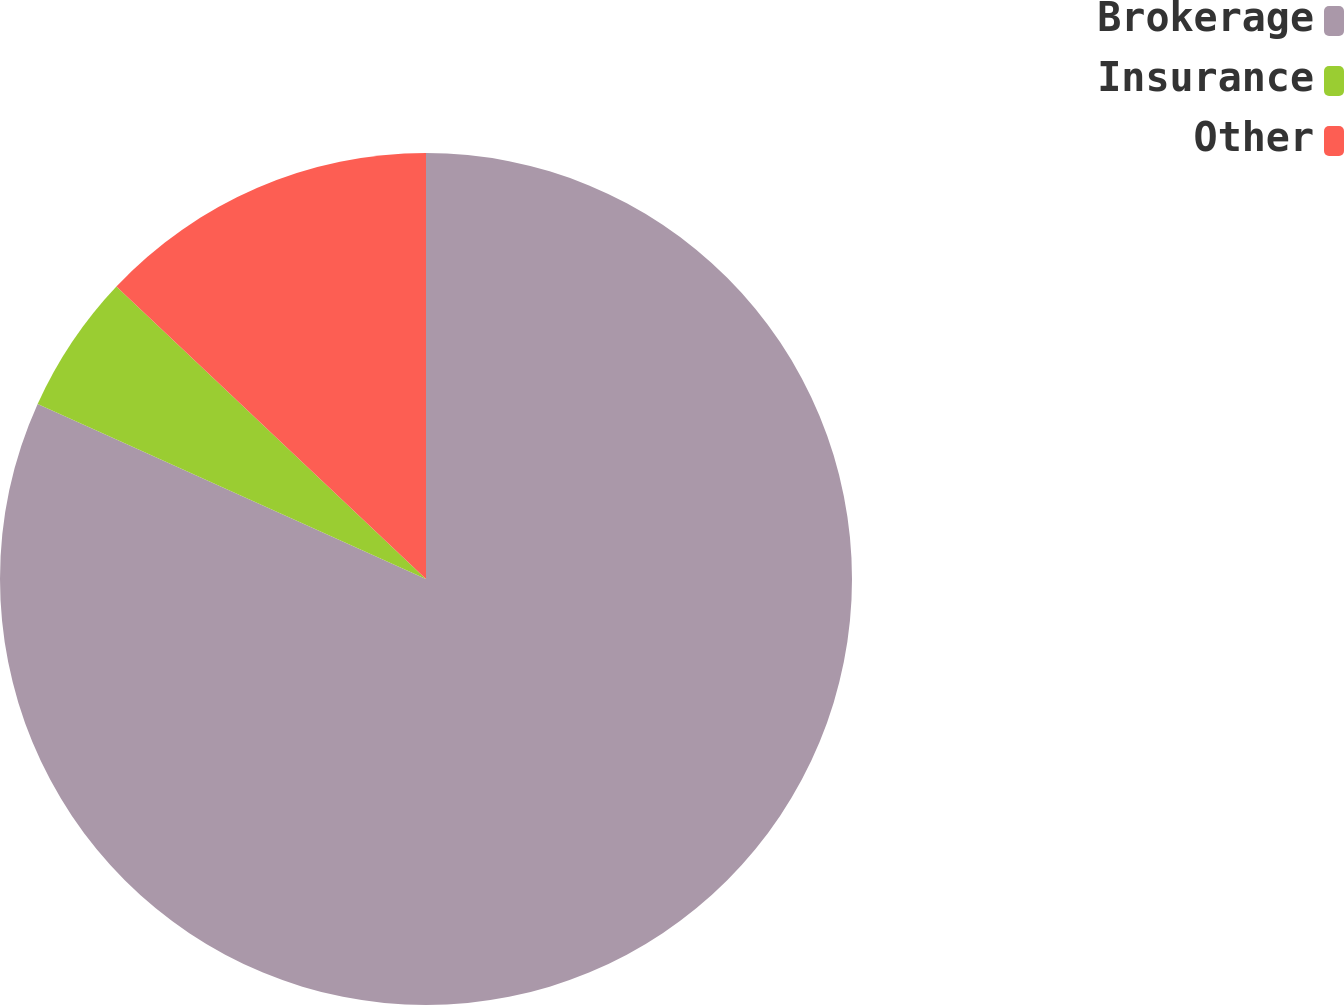<chart> <loc_0><loc_0><loc_500><loc_500><pie_chart><fcel>Brokerage<fcel>Insurance<fcel>Other<nl><fcel>81.75%<fcel>5.31%<fcel>12.95%<nl></chart> 